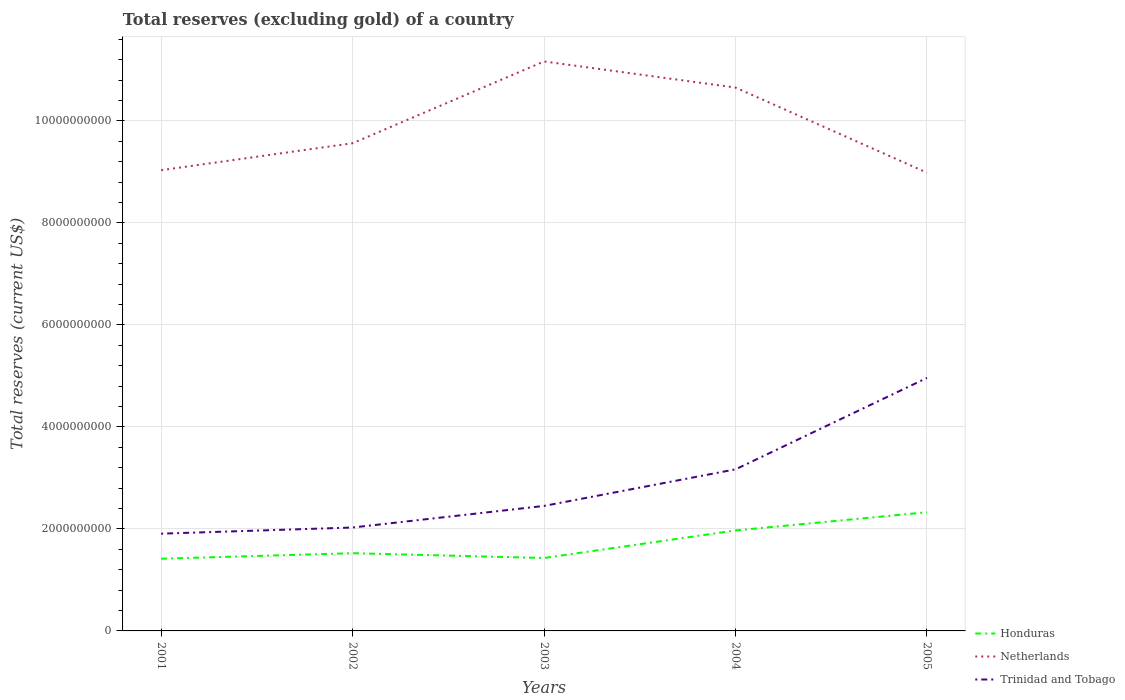How many different coloured lines are there?
Offer a very short reply. 3. Is the number of lines equal to the number of legend labels?
Offer a terse response. Yes. Across all years, what is the maximum total reserves (excluding gold) in Trinidad and Tobago?
Your answer should be very brief. 1.91e+09. What is the total total reserves (excluding gold) in Trinidad and Tobago in the graph?
Your response must be concise. -3.05e+09. What is the difference between the highest and the second highest total reserves (excluding gold) in Honduras?
Your answer should be very brief. 9.12e+08. What is the difference between the highest and the lowest total reserves (excluding gold) in Honduras?
Your answer should be compact. 2. How many years are there in the graph?
Make the answer very short. 5. Are the values on the major ticks of Y-axis written in scientific E-notation?
Your response must be concise. No. How are the legend labels stacked?
Offer a very short reply. Vertical. What is the title of the graph?
Keep it short and to the point. Total reserves (excluding gold) of a country. Does "Fragile and conflict affected situations" appear as one of the legend labels in the graph?
Make the answer very short. No. What is the label or title of the X-axis?
Give a very brief answer. Years. What is the label or title of the Y-axis?
Provide a short and direct response. Total reserves (current US$). What is the Total reserves (current US$) in Honduras in 2001?
Make the answer very short. 1.42e+09. What is the Total reserves (current US$) of Netherlands in 2001?
Give a very brief answer. 9.03e+09. What is the Total reserves (current US$) in Trinidad and Tobago in 2001?
Provide a short and direct response. 1.91e+09. What is the Total reserves (current US$) in Honduras in 2002?
Make the answer very short. 1.52e+09. What is the Total reserves (current US$) of Netherlands in 2002?
Give a very brief answer. 9.56e+09. What is the Total reserves (current US$) of Trinidad and Tobago in 2002?
Make the answer very short. 2.03e+09. What is the Total reserves (current US$) of Honduras in 2003?
Your answer should be compact. 1.43e+09. What is the Total reserves (current US$) of Netherlands in 2003?
Give a very brief answer. 1.12e+1. What is the Total reserves (current US$) of Trinidad and Tobago in 2003?
Your answer should be very brief. 2.45e+09. What is the Total reserves (current US$) in Honduras in 2004?
Give a very brief answer. 1.97e+09. What is the Total reserves (current US$) of Netherlands in 2004?
Your answer should be very brief. 1.07e+1. What is the Total reserves (current US$) of Trinidad and Tobago in 2004?
Your response must be concise. 3.17e+09. What is the Total reserves (current US$) in Honduras in 2005?
Your response must be concise. 2.33e+09. What is the Total reserves (current US$) in Netherlands in 2005?
Your response must be concise. 8.99e+09. What is the Total reserves (current US$) of Trinidad and Tobago in 2005?
Provide a short and direct response. 4.96e+09. Across all years, what is the maximum Total reserves (current US$) in Honduras?
Give a very brief answer. 2.33e+09. Across all years, what is the maximum Total reserves (current US$) of Netherlands?
Ensure brevity in your answer.  1.12e+1. Across all years, what is the maximum Total reserves (current US$) in Trinidad and Tobago?
Ensure brevity in your answer.  4.96e+09. Across all years, what is the minimum Total reserves (current US$) of Honduras?
Ensure brevity in your answer.  1.42e+09. Across all years, what is the minimum Total reserves (current US$) of Netherlands?
Keep it short and to the point. 8.99e+09. Across all years, what is the minimum Total reserves (current US$) of Trinidad and Tobago?
Your answer should be very brief. 1.91e+09. What is the total Total reserves (current US$) in Honduras in the graph?
Provide a succinct answer. 8.67e+09. What is the total Total reserves (current US$) in Netherlands in the graph?
Make the answer very short. 4.94e+1. What is the total Total reserves (current US$) of Trinidad and Tobago in the graph?
Provide a succinct answer. 1.45e+1. What is the difference between the Total reserves (current US$) in Honduras in 2001 and that in 2002?
Offer a terse response. -1.09e+08. What is the difference between the Total reserves (current US$) in Netherlands in 2001 and that in 2002?
Ensure brevity in your answer.  -5.29e+08. What is the difference between the Total reserves (current US$) of Trinidad and Tobago in 2001 and that in 2002?
Your answer should be very brief. -1.21e+08. What is the difference between the Total reserves (current US$) in Honduras in 2001 and that in 2003?
Keep it short and to the point. -1.45e+07. What is the difference between the Total reserves (current US$) of Netherlands in 2001 and that in 2003?
Offer a terse response. -2.13e+09. What is the difference between the Total reserves (current US$) in Trinidad and Tobago in 2001 and that in 2003?
Offer a terse response. -5.44e+08. What is the difference between the Total reserves (current US$) of Honduras in 2001 and that in 2004?
Keep it short and to the point. -5.55e+08. What is the difference between the Total reserves (current US$) of Netherlands in 2001 and that in 2004?
Your response must be concise. -1.62e+09. What is the difference between the Total reserves (current US$) in Trinidad and Tobago in 2001 and that in 2004?
Provide a short and direct response. -1.26e+09. What is the difference between the Total reserves (current US$) in Honduras in 2001 and that in 2005?
Ensure brevity in your answer.  -9.12e+08. What is the difference between the Total reserves (current US$) of Netherlands in 2001 and that in 2005?
Offer a terse response. 4.84e+07. What is the difference between the Total reserves (current US$) of Trinidad and Tobago in 2001 and that in 2005?
Your answer should be compact. -3.05e+09. What is the difference between the Total reserves (current US$) of Honduras in 2002 and that in 2003?
Provide a short and direct response. 9.41e+07. What is the difference between the Total reserves (current US$) in Netherlands in 2002 and that in 2003?
Your answer should be very brief. -1.60e+09. What is the difference between the Total reserves (current US$) of Trinidad and Tobago in 2002 and that in 2003?
Your answer should be compact. -4.23e+08. What is the difference between the Total reserves (current US$) in Honduras in 2002 and that in 2004?
Your response must be concise. -4.46e+08. What is the difference between the Total reserves (current US$) of Netherlands in 2002 and that in 2004?
Provide a short and direct response. -1.09e+09. What is the difference between the Total reserves (current US$) in Trinidad and Tobago in 2002 and that in 2004?
Your response must be concise. -1.14e+09. What is the difference between the Total reserves (current US$) of Honduras in 2002 and that in 2005?
Give a very brief answer. -8.03e+08. What is the difference between the Total reserves (current US$) in Netherlands in 2002 and that in 2005?
Give a very brief answer. 5.77e+08. What is the difference between the Total reserves (current US$) of Trinidad and Tobago in 2002 and that in 2005?
Your answer should be compact. -2.93e+09. What is the difference between the Total reserves (current US$) of Honduras in 2003 and that in 2004?
Your response must be concise. -5.40e+08. What is the difference between the Total reserves (current US$) of Netherlands in 2003 and that in 2004?
Your answer should be compact. 5.12e+08. What is the difference between the Total reserves (current US$) in Trinidad and Tobago in 2003 and that in 2004?
Make the answer very short. -7.17e+08. What is the difference between the Total reserves (current US$) of Honduras in 2003 and that in 2005?
Your response must be concise. -8.97e+08. What is the difference between the Total reserves (current US$) of Netherlands in 2003 and that in 2005?
Make the answer very short. 2.18e+09. What is the difference between the Total reserves (current US$) of Trinidad and Tobago in 2003 and that in 2005?
Provide a short and direct response. -2.51e+09. What is the difference between the Total reserves (current US$) of Honduras in 2004 and that in 2005?
Provide a succinct answer. -3.57e+08. What is the difference between the Total reserves (current US$) of Netherlands in 2004 and that in 2005?
Ensure brevity in your answer.  1.67e+09. What is the difference between the Total reserves (current US$) of Trinidad and Tobago in 2004 and that in 2005?
Your answer should be compact. -1.79e+09. What is the difference between the Total reserves (current US$) of Honduras in 2001 and the Total reserves (current US$) of Netherlands in 2002?
Make the answer very short. -8.15e+09. What is the difference between the Total reserves (current US$) in Honduras in 2001 and the Total reserves (current US$) in Trinidad and Tobago in 2002?
Offer a very short reply. -6.12e+08. What is the difference between the Total reserves (current US$) in Netherlands in 2001 and the Total reserves (current US$) in Trinidad and Tobago in 2002?
Your answer should be compact. 7.01e+09. What is the difference between the Total reserves (current US$) of Honduras in 2001 and the Total reserves (current US$) of Netherlands in 2003?
Keep it short and to the point. -9.75e+09. What is the difference between the Total reserves (current US$) in Honduras in 2001 and the Total reserves (current US$) in Trinidad and Tobago in 2003?
Offer a terse response. -1.04e+09. What is the difference between the Total reserves (current US$) of Netherlands in 2001 and the Total reserves (current US$) of Trinidad and Tobago in 2003?
Provide a succinct answer. 6.58e+09. What is the difference between the Total reserves (current US$) of Honduras in 2001 and the Total reserves (current US$) of Netherlands in 2004?
Your answer should be very brief. -9.24e+09. What is the difference between the Total reserves (current US$) of Honduras in 2001 and the Total reserves (current US$) of Trinidad and Tobago in 2004?
Offer a very short reply. -1.75e+09. What is the difference between the Total reserves (current US$) of Netherlands in 2001 and the Total reserves (current US$) of Trinidad and Tobago in 2004?
Make the answer very short. 5.87e+09. What is the difference between the Total reserves (current US$) of Honduras in 2001 and the Total reserves (current US$) of Netherlands in 2005?
Provide a short and direct response. -7.57e+09. What is the difference between the Total reserves (current US$) of Honduras in 2001 and the Total reserves (current US$) of Trinidad and Tobago in 2005?
Keep it short and to the point. -3.55e+09. What is the difference between the Total reserves (current US$) in Netherlands in 2001 and the Total reserves (current US$) in Trinidad and Tobago in 2005?
Make the answer very short. 4.07e+09. What is the difference between the Total reserves (current US$) in Honduras in 2002 and the Total reserves (current US$) in Netherlands in 2003?
Provide a succinct answer. -9.64e+09. What is the difference between the Total reserves (current US$) of Honduras in 2002 and the Total reserves (current US$) of Trinidad and Tobago in 2003?
Make the answer very short. -9.27e+08. What is the difference between the Total reserves (current US$) in Netherlands in 2002 and the Total reserves (current US$) in Trinidad and Tobago in 2003?
Your answer should be compact. 7.11e+09. What is the difference between the Total reserves (current US$) in Honduras in 2002 and the Total reserves (current US$) in Netherlands in 2004?
Offer a very short reply. -9.13e+09. What is the difference between the Total reserves (current US$) in Honduras in 2002 and the Total reserves (current US$) in Trinidad and Tobago in 2004?
Make the answer very short. -1.64e+09. What is the difference between the Total reserves (current US$) in Netherlands in 2002 and the Total reserves (current US$) in Trinidad and Tobago in 2004?
Provide a short and direct response. 6.40e+09. What is the difference between the Total reserves (current US$) in Honduras in 2002 and the Total reserves (current US$) in Netherlands in 2005?
Your answer should be compact. -7.46e+09. What is the difference between the Total reserves (current US$) in Honduras in 2002 and the Total reserves (current US$) in Trinidad and Tobago in 2005?
Provide a short and direct response. -3.44e+09. What is the difference between the Total reserves (current US$) of Netherlands in 2002 and the Total reserves (current US$) of Trinidad and Tobago in 2005?
Provide a succinct answer. 4.60e+09. What is the difference between the Total reserves (current US$) of Honduras in 2003 and the Total reserves (current US$) of Netherlands in 2004?
Your answer should be compact. -9.22e+09. What is the difference between the Total reserves (current US$) in Honduras in 2003 and the Total reserves (current US$) in Trinidad and Tobago in 2004?
Provide a short and direct response. -1.74e+09. What is the difference between the Total reserves (current US$) in Netherlands in 2003 and the Total reserves (current US$) in Trinidad and Tobago in 2004?
Provide a succinct answer. 8.00e+09. What is the difference between the Total reserves (current US$) in Honduras in 2003 and the Total reserves (current US$) in Netherlands in 2005?
Your response must be concise. -7.56e+09. What is the difference between the Total reserves (current US$) in Honduras in 2003 and the Total reserves (current US$) in Trinidad and Tobago in 2005?
Offer a very short reply. -3.53e+09. What is the difference between the Total reserves (current US$) of Netherlands in 2003 and the Total reserves (current US$) of Trinidad and Tobago in 2005?
Offer a very short reply. 6.21e+09. What is the difference between the Total reserves (current US$) of Honduras in 2004 and the Total reserves (current US$) of Netherlands in 2005?
Keep it short and to the point. -7.02e+09. What is the difference between the Total reserves (current US$) of Honduras in 2004 and the Total reserves (current US$) of Trinidad and Tobago in 2005?
Ensure brevity in your answer.  -2.99e+09. What is the difference between the Total reserves (current US$) in Netherlands in 2004 and the Total reserves (current US$) in Trinidad and Tobago in 2005?
Make the answer very short. 5.69e+09. What is the average Total reserves (current US$) in Honduras per year?
Provide a short and direct response. 1.73e+09. What is the average Total reserves (current US$) in Netherlands per year?
Your answer should be compact. 9.88e+09. What is the average Total reserves (current US$) in Trinidad and Tobago per year?
Your answer should be very brief. 2.90e+09. In the year 2001, what is the difference between the Total reserves (current US$) of Honduras and Total reserves (current US$) of Netherlands?
Your response must be concise. -7.62e+09. In the year 2001, what is the difference between the Total reserves (current US$) in Honduras and Total reserves (current US$) in Trinidad and Tobago?
Offer a terse response. -4.92e+08. In the year 2001, what is the difference between the Total reserves (current US$) of Netherlands and Total reserves (current US$) of Trinidad and Tobago?
Your answer should be compact. 7.13e+09. In the year 2002, what is the difference between the Total reserves (current US$) of Honduras and Total reserves (current US$) of Netherlands?
Provide a short and direct response. -8.04e+09. In the year 2002, what is the difference between the Total reserves (current US$) of Honduras and Total reserves (current US$) of Trinidad and Tobago?
Offer a very short reply. -5.04e+08. In the year 2002, what is the difference between the Total reserves (current US$) of Netherlands and Total reserves (current US$) of Trinidad and Tobago?
Your answer should be compact. 7.54e+09. In the year 2003, what is the difference between the Total reserves (current US$) in Honduras and Total reserves (current US$) in Netherlands?
Make the answer very short. -9.74e+09. In the year 2003, what is the difference between the Total reserves (current US$) in Honduras and Total reserves (current US$) in Trinidad and Tobago?
Keep it short and to the point. -1.02e+09. In the year 2003, what is the difference between the Total reserves (current US$) of Netherlands and Total reserves (current US$) of Trinidad and Tobago?
Your answer should be very brief. 8.72e+09. In the year 2004, what is the difference between the Total reserves (current US$) of Honduras and Total reserves (current US$) of Netherlands?
Offer a very short reply. -8.68e+09. In the year 2004, what is the difference between the Total reserves (current US$) in Honduras and Total reserves (current US$) in Trinidad and Tobago?
Offer a very short reply. -1.20e+09. In the year 2004, what is the difference between the Total reserves (current US$) of Netherlands and Total reserves (current US$) of Trinidad and Tobago?
Give a very brief answer. 7.49e+09. In the year 2005, what is the difference between the Total reserves (current US$) of Honduras and Total reserves (current US$) of Netherlands?
Provide a short and direct response. -6.66e+09. In the year 2005, what is the difference between the Total reserves (current US$) in Honduras and Total reserves (current US$) in Trinidad and Tobago?
Offer a very short reply. -2.63e+09. In the year 2005, what is the difference between the Total reserves (current US$) in Netherlands and Total reserves (current US$) in Trinidad and Tobago?
Offer a very short reply. 4.03e+09. What is the ratio of the Total reserves (current US$) in Honduras in 2001 to that in 2002?
Give a very brief answer. 0.93. What is the ratio of the Total reserves (current US$) of Netherlands in 2001 to that in 2002?
Give a very brief answer. 0.94. What is the ratio of the Total reserves (current US$) in Trinidad and Tobago in 2001 to that in 2002?
Keep it short and to the point. 0.94. What is the ratio of the Total reserves (current US$) of Netherlands in 2001 to that in 2003?
Keep it short and to the point. 0.81. What is the ratio of the Total reserves (current US$) in Trinidad and Tobago in 2001 to that in 2003?
Your answer should be very brief. 0.78. What is the ratio of the Total reserves (current US$) of Honduras in 2001 to that in 2004?
Provide a succinct answer. 0.72. What is the ratio of the Total reserves (current US$) in Netherlands in 2001 to that in 2004?
Give a very brief answer. 0.85. What is the ratio of the Total reserves (current US$) in Trinidad and Tobago in 2001 to that in 2004?
Your answer should be compact. 0.6. What is the ratio of the Total reserves (current US$) of Honduras in 2001 to that in 2005?
Your response must be concise. 0.61. What is the ratio of the Total reserves (current US$) in Netherlands in 2001 to that in 2005?
Offer a terse response. 1.01. What is the ratio of the Total reserves (current US$) in Trinidad and Tobago in 2001 to that in 2005?
Offer a terse response. 0.38. What is the ratio of the Total reserves (current US$) of Honduras in 2002 to that in 2003?
Ensure brevity in your answer.  1.07. What is the ratio of the Total reserves (current US$) of Netherlands in 2002 to that in 2003?
Your answer should be compact. 0.86. What is the ratio of the Total reserves (current US$) in Trinidad and Tobago in 2002 to that in 2003?
Provide a short and direct response. 0.83. What is the ratio of the Total reserves (current US$) of Honduras in 2002 to that in 2004?
Offer a terse response. 0.77. What is the ratio of the Total reserves (current US$) in Netherlands in 2002 to that in 2004?
Give a very brief answer. 0.9. What is the ratio of the Total reserves (current US$) of Trinidad and Tobago in 2002 to that in 2004?
Keep it short and to the point. 0.64. What is the ratio of the Total reserves (current US$) in Honduras in 2002 to that in 2005?
Offer a very short reply. 0.65. What is the ratio of the Total reserves (current US$) in Netherlands in 2002 to that in 2005?
Your answer should be compact. 1.06. What is the ratio of the Total reserves (current US$) of Trinidad and Tobago in 2002 to that in 2005?
Your answer should be very brief. 0.41. What is the ratio of the Total reserves (current US$) of Honduras in 2003 to that in 2004?
Ensure brevity in your answer.  0.73. What is the ratio of the Total reserves (current US$) of Netherlands in 2003 to that in 2004?
Ensure brevity in your answer.  1.05. What is the ratio of the Total reserves (current US$) of Trinidad and Tobago in 2003 to that in 2004?
Your response must be concise. 0.77. What is the ratio of the Total reserves (current US$) in Honduras in 2003 to that in 2005?
Give a very brief answer. 0.61. What is the ratio of the Total reserves (current US$) of Netherlands in 2003 to that in 2005?
Provide a short and direct response. 1.24. What is the ratio of the Total reserves (current US$) in Trinidad and Tobago in 2003 to that in 2005?
Ensure brevity in your answer.  0.49. What is the ratio of the Total reserves (current US$) of Honduras in 2004 to that in 2005?
Ensure brevity in your answer.  0.85. What is the ratio of the Total reserves (current US$) in Netherlands in 2004 to that in 2005?
Provide a short and direct response. 1.19. What is the ratio of the Total reserves (current US$) of Trinidad and Tobago in 2004 to that in 2005?
Offer a very short reply. 0.64. What is the difference between the highest and the second highest Total reserves (current US$) in Honduras?
Ensure brevity in your answer.  3.57e+08. What is the difference between the highest and the second highest Total reserves (current US$) in Netherlands?
Offer a very short reply. 5.12e+08. What is the difference between the highest and the second highest Total reserves (current US$) of Trinidad and Tobago?
Your response must be concise. 1.79e+09. What is the difference between the highest and the lowest Total reserves (current US$) in Honduras?
Provide a short and direct response. 9.12e+08. What is the difference between the highest and the lowest Total reserves (current US$) in Netherlands?
Provide a short and direct response. 2.18e+09. What is the difference between the highest and the lowest Total reserves (current US$) in Trinidad and Tobago?
Your answer should be very brief. 3.05e+09. 